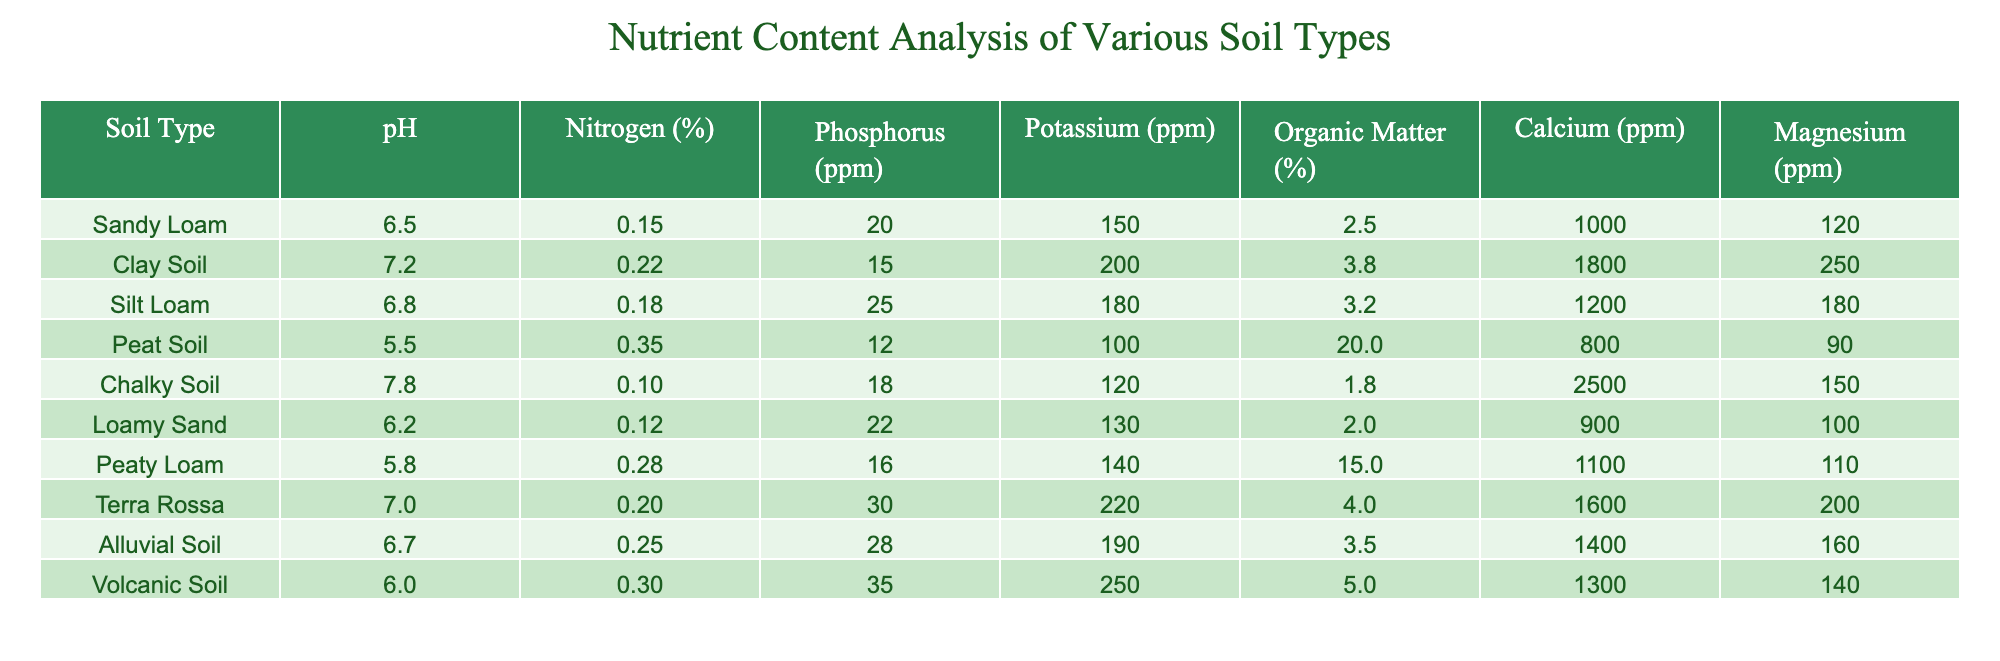What is the pH level of Peat Soil? The pH level for Peat Soil is listed directly in the table under the pH column. It shows 5.5.
Answer: 5.5 Which soil type has the highest Nitrogen content? By comparing the Nitrogen percentages across all soil types, Peat Soil has the highest at 0.35%.
Answer: Peat Soil What is the average Potassium content across all soil types? To find the average, sum the Potassium values: (150 + 200 + 180 + 100 + 120 + 130 + 140 + 220 + 190 + 250) = 1880, and divide by the number of soil types (10): 1880/10 = 188.
Answer: 188 Is Clay Soil richer in Phosphorus than Chalky Soil? Clay Soil has 15 ppm of Phosphorus, while Chalky Soil has 18 ppm. Since 15 is less than 18, Clay Soil is not richer in Phosphorus.
Answer: No Which soil type has the lowest Organic Matter percentage? The Organic Matter percentages can be scanned across all types, and Loamy Sand has the lowest at 2.0%.
Answer: Loamy Sand If we combine the Calcium content from Sandy Loam and Silt Loam, what is the total? The Calcium content for Sandy Loam is 1000 ppm and for Silt Loam is 1200 ppm. Their sum is 1000 + 1200 = 2200 ppm.
Answer: 2200 ppm Is the Magnesium content in Terra Rossa higher than the average Magnesium content of all soil types? First, find the average Magnesium content: (120 + 250 + 180 + 90 + 150 + 100 + 110 + 200 + 160 + 140) = 1450, dividing by 10 gives an average of 145. Terra Rossa has 200 ppm, which is higher than 145 ppm.
Answer: Yes What is the difference in Nitrogen content between Peaty Loam and Sandy Loam? Peaty Loam has 0.28% Nitrogen, while Sandy Loam has 0.15%. The difference is 0.28 - 0.15 = 0.13%.
Answer: 0.13% 